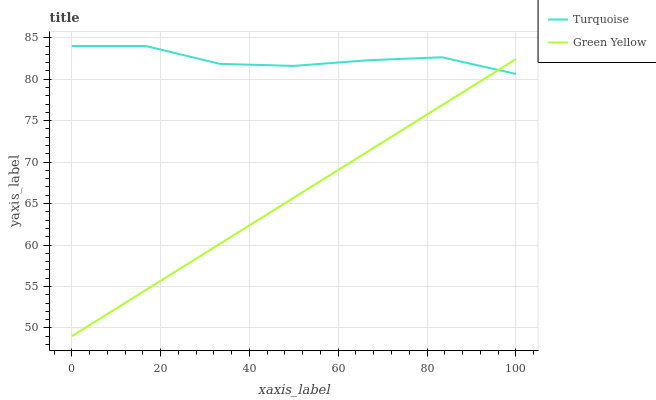Does Green Yellow have the minimum area under the curve?
Answer yes or no. Yes. Does Turquoise have the maximum area under the curve?
Answer yes or no. Yes. Does Green Yellow have the maximum area under the curve?
Answer yes or no. No. Is Green Yellow the smoothest?
Answer yes or no. Yes. Is Turquoise the roughest?
Answer yes or no. Yes. Is Green Yellow the roughest?
Answer yes or no. No. Does Green Yellow have the highest value?
Answer yes or no. No. 